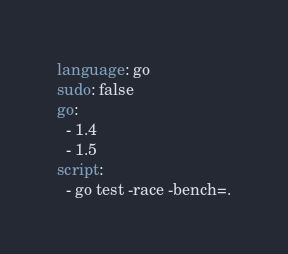<code> <loc_0><loc_0><loc_500><loc_500><_YAML_>language: go
sudo: false
go:
  - 1.4
  - 1.5
script:
  - go test -race -bench=.
</code> 